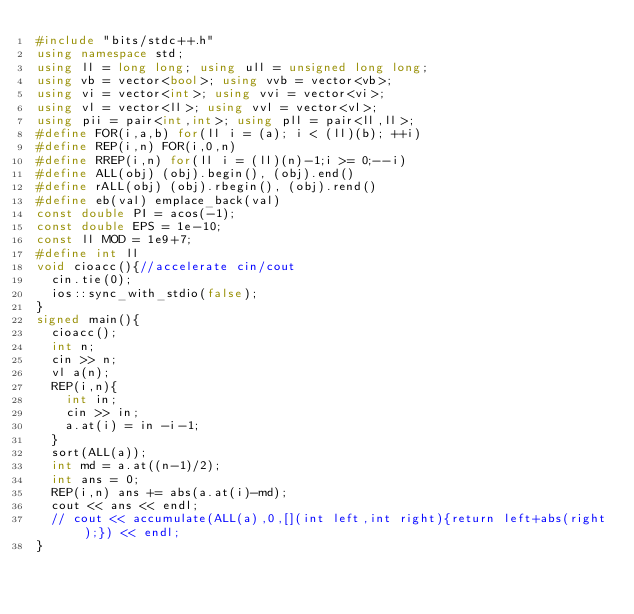<code> <loc_0><loc_0><loc_500><loc_500><_C++_>#include "bits/stdc++.h"
using namespace std;
using ll = long long; using ull = unsigned long long;
using vb = vector<bool>; using vvb = vector<vb>;
using vi = vector<int>; using vvi = vector<vi>;
using vl = vector<ll>; using vvl = vector<vl>;
using pii = pair<int,int>; using pll = pair<ll,ll>;
#define FOR(i,a,b) for(ll i = (a); i < (ll)(b); ++i)
#define REP(i,n) FOR(i,0,n)
#define RREP(i,n) for(ll i = (ll)(n)-1;i >= 0;--i)
#define ALL(obj) (obj).begin(), (obj).end()
#define rALL(obj) (obj).rbegin(), (obj).rend()
#define eb(val) emplace_back(val)
const double PI = acos(-1);
const double EPS = 1e-10;
const ll MOD = 1e9+7;
#define int ll
void cioacc(){//accelerate cin/cout
  cin.tie(0);
  ios::sync_with_stdio(false);
}
signed main(){
  cioacc();
  int n;
  cin >> n;
  vl a(n);
  REP(i,n){
    int in;
    cin >> in;
    a.at(i) = in -i-1;
  }
  sort(ALL(a));
  int md = a.at((n-1)/2);
  int ans = 0;
  REP(i,n) ans += abs(a.at(i)-md);
  cout << ans << endl;
  // cout << accumulate(ALL(a),0,[](int left,int right){return left+abs(right);}) << endl;
}</code> 